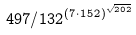<formula> <loc_0><loc_0><loc_500><loc_500>4 9 7 / 1 3 2 ^ { ( 7 \cdot 1 5 2 ) ^ { \sqrt { 2 0 2 } } }</formula> 